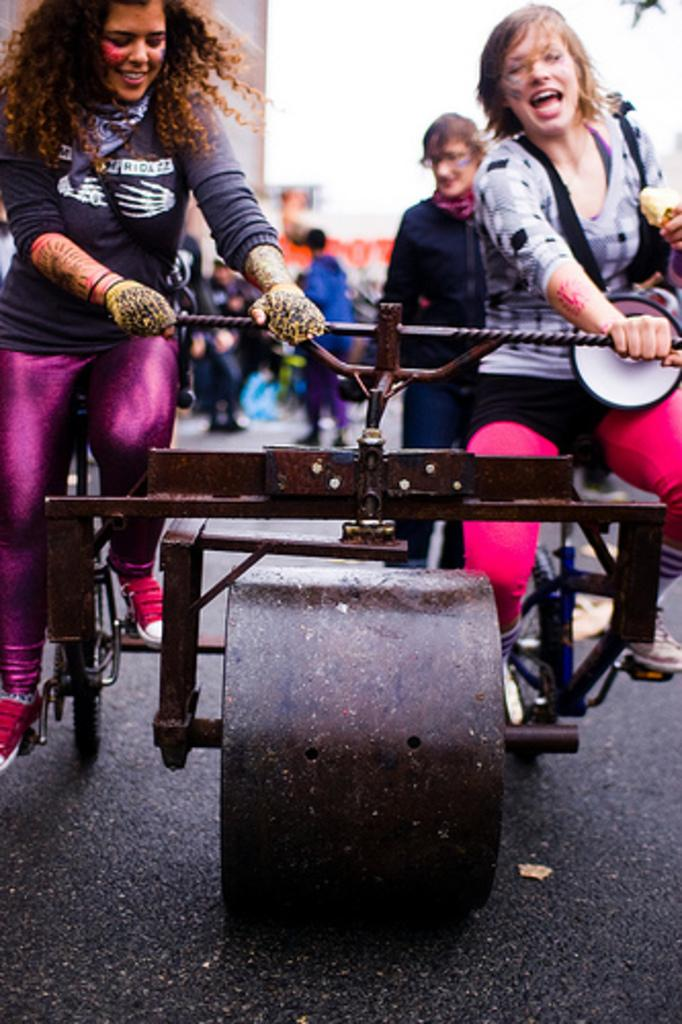How many women are in the image? There are two women in the image. What are the women doing in the image? The women are sitting on a vehicle and smiling. Can you describe the people in the background of the image? There is a group of people standing on the road in the background of the image. What can be seen in the distance behind the people? There are buildings visible in the background of the image, and the background appears blurry. What type of skirt is the woman wearing in the image? There is no information about the women's clothing in the image, so we cannot determine if they are wearing skirts. What need does the ticket serve in the image? There is no ticket present in the image, so we cannot determine its purpose. 